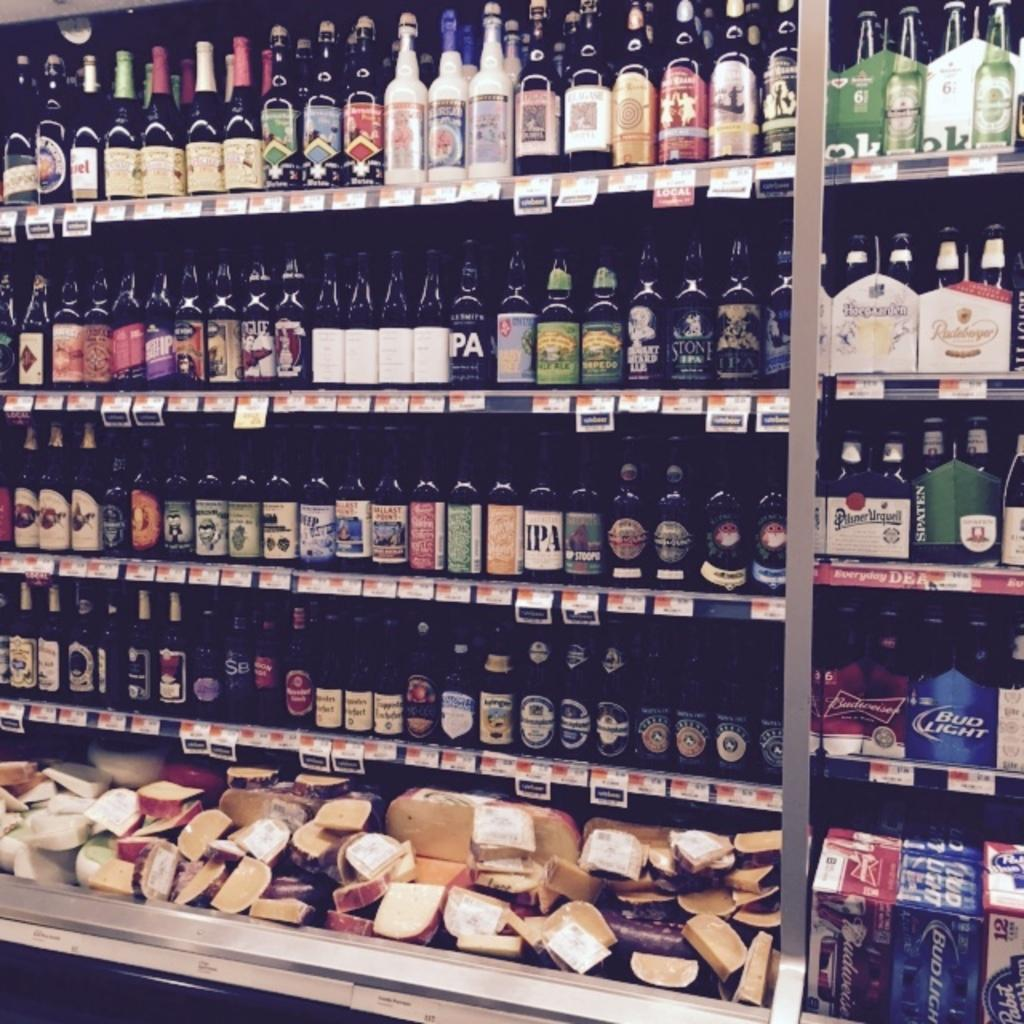<image>
Render a clear and concise summary of the photo. Alcohol store selling different alcohol including Bud Light. 